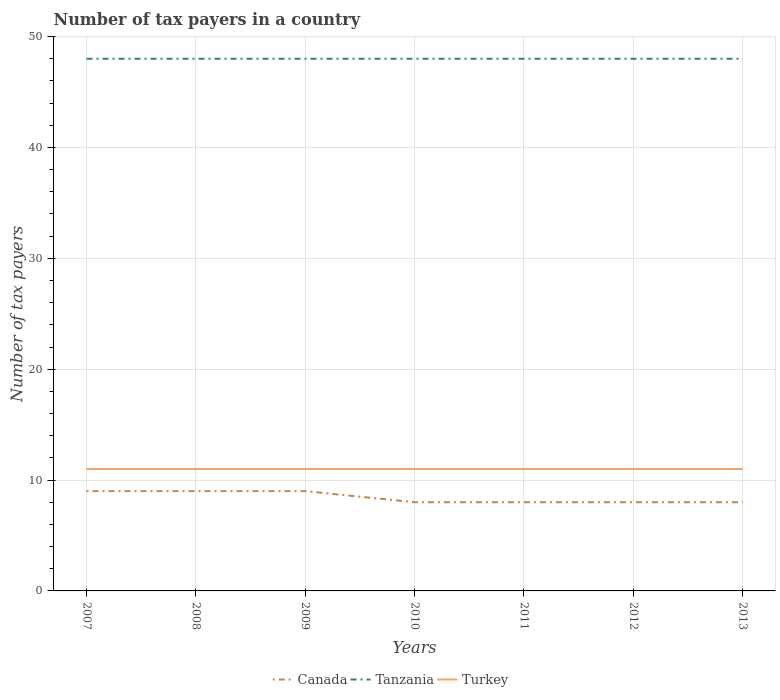Does the line corresponding to Canada intersect with the line corresponding to Tanzania?
Offer a terse response. No. Is the number of lines equal to the number of legend labels?
Your answer should be compact. Yes. Across all years, what is the maximum number of tax payers in in Tanzania?
Provide a short and direct response. 48. In which year was the number of tax payers in in Tanzania maximum?
Your answer should be compact. 2007. What is the total number of tax payers in in Tanzania in the graph?
Ensure brevity in your answer.  0. What is the difference between the highest and the second highest number of tax payers in in Tanzania?
Ensure brevity in your answer.  0. How many years are there in the graph?
Offer a terse response. 7. Are the values on the major ticks of Y-axis written in scientific E-notation?
Offer a very short reply. No. Does the graph contain any zero values?
Your response must be concise. No. How many legend labels are there?
Make the answer very short. 3. How are the legend labels stacked?
Give a very brief answer. Horizontal. What is the title of the graph?
Offer a very short reply. Number of tax payers in a country. What is the label or title of the Y-axis?
Offer a very short reply. Number of tax payers. What is the Number of tax payers of Canada in 2007?
Make the answer very short. 9. What is the Number of tax payers in Tanzania in 2008?
Your response must be concise. 48. What is the Number of tax payers of Tanzania in 2009?
Give a very brief answer. 48. What is the Number of tax payers of Tanzania in 2010?
Provide a short and direct response. 48. What is the Number of tax payers of Canada in 2013?
Your response must be concise. 8. What is the Number of tax payers in Tanzania in 2013?
Your answer should be very brief. 48. What is the Number of tax payers of Turkey in 2013?
Your answer should be compact. 11. Across all years, what is the maximum Number of tax payers of Tanzania?
Provide a short and direct response. 48. What is the total Number of tax payers of Canada in the graph?
Your answer should be compact. 59. What is the total Number of tax payers in Tanzania in the graph?
Your response must be concise. 336. What is the difference between the Number of tax payers in Canada in 2007 and that in 2008?
Offer a very short reply. 0. What is the difference between the Number of tax payers in Canada in 2007 and that in 2009?
Provide a short and direct response. 0. What is the difference between the Number of tax payers in Tanzania in 2007 and that in 2009?
Provide a succinct answer. 0. What is the difference between the Number of tax payers of Canada in 2007 and that in 2010?
Keep it short and to the point. 1. What is the difference between the Number of tax payers in Tanzania in 2007 and that in 2010?
Ensure brevity in your answer.  0. What is the difference between the Number of tax payers in Turkey in 2007 and that in 2010?
Provide a succinct answer. 0. What is the difference between the Number of tax payers of Canada in 2007 and that in 2012?
Keep it short and to the point. 1. What is the difference between the Number of tax payers in Tanzania in 2007 and that in 2012?
Give a very brief answer. 0. What is the difference between the Number of tax payers in Turkey in 2007 and that in 2012?
Your answer should be compact. 0. What is the difference between the Number of tax payers in Canada in 2007 and that in 2013?
Give a very brief answer. 1. What is the difference between the Number of tax payers in Tanzania in 2007 and that in 2013?
Provide a succinct answer. 0. What is the difference between the Number of tax payers in Canada in 2008 and that in 2009?
Your response must be concise. 0. What is the difference between the Number of tax payers in Turkey in 2008 and that in 2009?
Provide a short and direct response. 0. What is the difference between the Number of tax payers in Tanzania in 2008 and that in 2010?
Your response must be concise. 0. What is the difference between the Number of tax payers of Tanzania in 2008 and that in 2011?
Your answer should be compact. 0. What is the difference between the Number of tax payers of Canada in 2008 and that in 2012?
Your answer should be compact. 1. What is the difference between the Number of tax payers in Turkey in 2008 and that in 2013?
Your answer should be compact. 0. What is the difference between the Number of tax payers of Canada in 2009 and that in 2010?
Offer a terse response. 1. What is the difference between the Number of tax payers of Tanzania in 2009 and that in 2010?
Offer a very short reply. 0. What is the difference between the Number of tax payers in Turkey in 2009 and that in 2010?
Ensure brevity in your answer.  0. What is the difference between the Number of tax payers in Canada in 2009 and that in 2011?
Keep it short and to the point. 1. What is the difference between the Number of tax payers of Turkey in 2009 and that in 2011?
Provide a succinct answer. 0. What is the difference between the Number of tax payers of Canada in 2009 and that in 2012?
Keep it short and to the point. 1. What is the difference between the Number of tax payers in Tanzania in 2009 and that in 2012?
Your answer should be very brief. 0. What is the difference between the Number of tax payers of Canada in 2009 and that in 2013?
Your answer should be compact. 1. What is the difference between the Number of tax payers of Turkey in 2009 and that in 2013?
Your answer should be very brief. 0. What is the difference between the Number of tax payers of Canada in 2010 and that in 2012?
Provide a short and direct response. 0. What is the difference between the Number of tax payers in Turkey in 2010 and that in 2012?
Keep it short and to the point. 0. What is the difference between the Number of tax payers of Canada in 2010 and that in 2013?
Provide a short and direct response. 0. What is the difference between the Number of tax payers in Turkey in 2010 and that in 2013?
Your answer should be compact. 0. What is the difference between the Number of tax payers in Canada in 2011 and that in 2013?
Keep it short and to the point. 0. What is the difference between the Number of tax payers in Tanzania in 2011 and that in 2013?
Your response must be concise. 0. What is the difference between the Number of tax payers of Canada in 2012 and that in 2013?
Offer a terse response. 0. What is the difference between the Number of tax payers of Turkey in 2012 and that in 2013?
Make the answer very short. 0. What is the difference between the Number of tax payers of Canada in 2007 and the Number of tax payers of Tanzania in 2008?
Your answer should be very brief. -39. What is the difference between the Number of tax payers of Canada in 2007 and the Number of tax payers of Tanzania in 2009?
Give a very brief answer. -39. What is the difference between the Number of tax payers in Canada in 2007 and the Number of tax payers in Turkey in 2009?
Offer a very short reply. -2. What is the difference between the Number of tax payers in Tanzania in 2007 and the Number of tax payers in Turkey in 2009?
Your answer should be compact. 37. What is the difference between the Number of tax payers in Canada in 2007 and the Number of tax payers in Tanzania in 2010?
Your answer should be compact. -39. What is the difference between the Number of tax payers of Canada in 2007 and the Number of tax payers of Turkey in 2010?
Provide a short and direct response. -2. What is the difference between the Number of tax payers in Canada in 2007 and the Number of tax payers in Tanzania in 2011?
Offer a very short reply. -39. What is the difference between the Number of tax payers of Canada in 2007 and the Number of tax payers of Turkey in 2011?
Make the answer very short. -2. What is the difference between the Number of tax payers of Tanzania in 2007 and the Number of tax payers of Turkey in 2011?
Provide a succinct answer. 37. What is the difference between the Number of tax payers in Canada in 2007 and the Number of tax payers in Tanzania in 2012?
Your answer should be compact. -39. What is the difference between the Number of tax payers in Canada in 2007 and the Number of tax payers in Turkey in 2012?
Give a very brief answer. -2. What is the difference between the Number of tax payers of Tanzania in 2007 and the Number of tax payers of Turkey in 2012?
Give a very brief answer. 37. What is the difference between the Number of tax payers of Canada in 2007 and the Number of tax payers of Tanzania in 2013?
Offer a very short reply. -39. What is the difference between the Number of tax payers of Canada in 2007 and the Number of tax payers of Turkey in 2013?
Ensure brevity in your answer.  -2. What is the difference between the Number of tax payers of Tanzania in 2007 and the Number of tax payers of Turkey in 2013?
Provide a succinct answer. 37. What is the difference between the Number of tax payers of Canada in 2008 and the Number of tax payers of Tanzania in 2009?
Your answer should be compact. -39. What is the difference between the Number of tax payers of Canada in 2008 and the Number of tax payers of Turkey in 2009?
Offer a terse response. -2. What is the difference between the Number of tax payers of Tanzania in 2008 and the Number of tax payers of Turkey in 2009?
Your response must be concise. 37. What is the difference between the Number of tax payers in Canada in 2008 and the Number of tax payers in Tanzania in 2010?
Your answer should be very brief. -39. What is the difference between the Number of tax payers of Canada in 2008 and the Number of tax payers of Turkey in 2010?
Make the answer very short. -2. What is the difference between the Number of tax payers in Canada in 2008 and the Number of tax payers in Tanzania in 2011?
Keep it short and to the point. -39. What is the difference between the Number of tax payers of Canada in 2008 and the Number of tax payers of Turkey in 2011?
Offer a very short reply. -2. What is the difference between the Number of tax payers in Tanzania in 2008 and the Number of tax payers in Turkey in 2011?
Make the answer very short. 37. What is the difference between the Number of tax payers of Canada in 2008 and the Number of tax payers of Tanzania in 2012?
Your answer should be compact. -39. What is the difference between the Number of tax payers in Canada in 2008 and the Number of tax payers in Tanzania in 2013?
Ensure brevity in your answer.  -39. What is the difference between the Number of tax payers in Tanzania in 2008 and the Number of tax payers in Turkey in 2013?
Make the answer very short. 37. What is the difference between the Number of tax payers of Canada in 2009 and the Number of tax payers of Tanzania in 2010?
Make the answer very short. -39. What is the difference between the Number of tax payers in Tanzania in 2009 and the Number of tax payers in Turkey in 2010?
Provide a short and direct response. 37. What is the difference between the Number of tax payers in Canada in 2009 and the Number of tax payers in Tanzania in 2011?
Your response must be concise. -39. What is the difference between the Number of tax payers in Canada in 2009 and the Number of tax payers in Turkey in 2011?
Keep it short and to the point. -2. What is the difference between the Number of tax payers in Canada in 2009 and the Number of tax payers in Tanzania in 2012?
Provide a succinct answer. -39. What is the difference between the Number of tax payers of Canada in 2009 and the Number of tax payers of Tanzania in 2013?
Your response must be concise. -39. What is the difference between the Number of tax payers of Canada in 2009 and the Number of tax payers of Turkey in 2013?
Your answer should be compact. -2. What is the difference between the Number of tax payers of Tanzania in 2010 and the Number of tax payers of Turkey in 2011?
Provide a short and direct response. 37. What is the difference between the Number of tax payers in Canada in 2011 and the Number of tax payers in Turkey in 2012?
Provide a succinct answer. -3. What is the difference between the Number of tax payers in Tanzania in 2011 and the Number of tax payers in Turkey in 2012?
Make the answer very short. 37. What is the difference between the Number of tax payers in Canada in 2011 and the Number of tax payers in Turkey in 2013?
Provide a succinct answer. -3. What is the difference between the Number of tax payers in Tanzania in 2011 and the Number of tax payers in Turkey in 2013?
Make the answer very short. 37. What is the difference between the Number of tax payers of Canada in 2012 and the Number of tax payers of Tanzania in 2013?
Your response must be concise. -40. What is the difference between the Number of tax payers in Canada in 2012 and the Number of tax payers in Turkey in 2013?
Ensure brevity in your answer.  -3. What is the average Number of tax payers in Canada per year?
Your answer should be compact. 8.43. What is the average Number of tax payers of Tanzania per year?
Your answer should be compact. 48. In the year 2007, what is the difference between the Number of tax payers in Canada and Number of tax payers in Tanzania?
Offer a terse response. -39. In the year 2008, what is the difference between the Number of tax payers of Canada and Number of tax payers of Tanzania?
Your answer should be compact. -39. In the year 2008, what is the difference between the Number of tax payers of Canada and Number of tax payers of Turkey?
Your answer should be very brief. -2. In the year 2009, what is the difference between the Number of tax payers of Canada and Number of tax payers of Tanzania?
Keep it short and to the point. -39. In the year 2009, what is the difference between the Number of tax payers in Canada and Number of tax payers in Turkey?
Ensure brevity in your answer.  -2. In the year 2009, what is the difference between the Number of tax payers of Tanzania and Number of tax payers of Turkey?
Make the answer very short. 37. In the year 2010, what is the difference between the Number of tax payers of Canada and Number of tax payers of Turkey?
Ensure brevity in your answer.  -3. In the year 2010, what is the difference between the Number of tax payers of Tanzania and Number of tax payers of Turkey?
Offer a very short reply. 37. In the year 2011, what is the difference between the Number of tax payers of Canada and Number of tax payers of Turkey?
Give a very brief answer. -3. In the year 2012, what is the difference between the Number of tax payers in Canada and Number of tax payers in Tanzania?
Provide a short and direct response. -40. In the year 2013, what is the difference between the Number of tax payers of Canada and Number of tax payers of Tanzania?
Your response must be concise. -40. In the year 2013, what is the difference between the Number of tax payers in Canada and Number of tax payers in Turkey?
Keep it short and to the point. -3. In the year 2013, what is the difference between the Number of tax payers of Tanzania and Number of tax payers of Turkey?
Your answer should be very brief. 37. What is the ratio of the Number of tax payers in Tanzania in 2007 to that in 2008?
Give a very brief answer. 1. What is the ratio of the Number of tax payers of Turkey in 2007 to that in 2008?
Provide a short and direct response. 1. What is the ratio of the Number of tax payers in Canada in 2007 to that in 2009?
Your answer should be very brief. 1. What is the ratio of the Number of tax payers in Tanzania in 2007 to that in 2009?
Offer a terse response. 1. What is the ratio of the Number of tax payers in Turkey in 2007 to that in 2009?
Offer a very short reply. 1. What is the ratio of the Number of tax payers in Canada in 2007 to that in 2010?
Ensure brevity in your answer.  1.12. What is the ratio of the Number of tax payers in Tanzania in 2007 to that in 2011?
Your response must be concise. 1. What is the ratio of the Number of tax payers in Turkey in 2007 to that in 2011?
Ensure brevity in your answer.  1. What is the ratio of the Number of tax payers of Tanzania in 2007 to that in 2012?
Your answer should be very brief. 1. What is the ratio of the Number of tax payers in Turkey in 2007 to that in 2012?
Offer a very short reply. 1. What is the ratio of the Number of tax payers of Tanzania in 2008 to that in 2009?
Your answer should be compact. 1. What is the ratio of the Number of tax payers in Tanzania in 2008 to that in 2010?
Ensure brevity in your answer.  1. What is the ratio of the Number of tax payers of Turkey in 2008 to that in 2011?
Keep it short and to the point. 1. What is the ratio of the Number of tax payers of Canada in 2008 to that in 2012?
Give a very brief answer. 1.12. What is the ratio of the Number of tax payers of Canada in 2008 to that in 2013?
Keep it short and to the point. 1.12. What is the ratio of the Number of tax payers in Tanzania in 2008 to that in 2013?
Provide a short and direct response. 1. What is the ratio of the Number of tax payers of Canada in 2009 to that in 2010?
Provide a short and direct response. 1.12. What is the ratio of the Number of tax payers of Tanzania in 2009 to that in 2010?
Your answer should be compact. 1. What is the ratio of the Number of tax payers of Turkey in 2009 to that in 2010?
Ensure brevity in your answer.  1. What is the ratio of the Number of tax payers of Canada in 2009 to that in 2011?
Your answer should be compact. 1.12. What is the ratio of the Number of tax payers of Tanzania in 2009 to that in 2011?
Make the answer very short. 1. What is the ratio of the Number of tax payers in Turkey in 2009 to that in 2011?
Provide a short and direct response. 1. What is the ratio of the Number of tax payers of Canada in 2009 to that in 2012?
Offer a very short reply. 1.12. What is the ratio of the Number of tax payers in Tanzania in 2009 to that in 2012?
Provide a short and direct response. 1. What is the ratio of the Number of tax payers of Canada in 2009 to that in 2013?
Offer a terse response. 1.12. What is the ratio of the Number of tax payers in Turkey in 2009 to that in 2013?
Give a very brief answer. 1. What is the ratio of the Number of tax payers in Canada in 2010 to that in 2011?
Your answer should be very brief. 1. What is the ratio of the Number of tax payers in Tanzania in 2010 to that in 2011?
Offer a terse response. 1. What is the ratio of the Number of tax payers of Turkey in 2010 to that in 2011?
Your response must be concise. 1. What is the ratio of the Number of tax payers in Canada in 2010 to that in 2012?
Provide a succinct answer. 1. What is the ratio of the Number of tax payers in Tanzania in 2010 to that in 2012?
Your answer should be very brief. 1. What is the ratio of the Number of tax payers of Tanzania in 2010 to that in 2013?
Keep it short and to the point. 1. What is the ratio of the Number of tax payers in Turkey in 2010 to that in 2013?
Your answer should be very brief. 1. What is the ratio of the Number of tax payers in Canada in 2011 to that in 2012?
Keep it short and to the point. 1. What is the ratio of the Number of tax payers of Turkey in 2011 to that in 2012?
Make the answer very short. 1. What is the ratio of the Number of tax payers in Turkey in 2011 to that in 2013?
Keep it short and to the point. 1. What is the ratio of the Number of tax payers of Canada in 2012 to that in 2013?
Ensure brevity in your answer.  1. What is the difference between the highest and the second highest Number of tax payers of Canada?
Keep it short and to the point. 0. What is the difference between the highest and the second highest Number of tax payers of Tanzania?
Provide a succinct answer. 0. What is the difference between the highest and the second highest Number of tax payers in Turkey?
Your answer should be compact. 0. What is the difference between the highest and the lowest Number of tax payers of Canada?
Ensure brevity in your answer.  1. What is the difference between the highest and the lowest Number of tax payers in Tanzania?
Ensure brevity in your answer.  0. What is the difference between the highest and the lowest Number of tax payers of Turkey?
Provide a short and direct response. 0. 